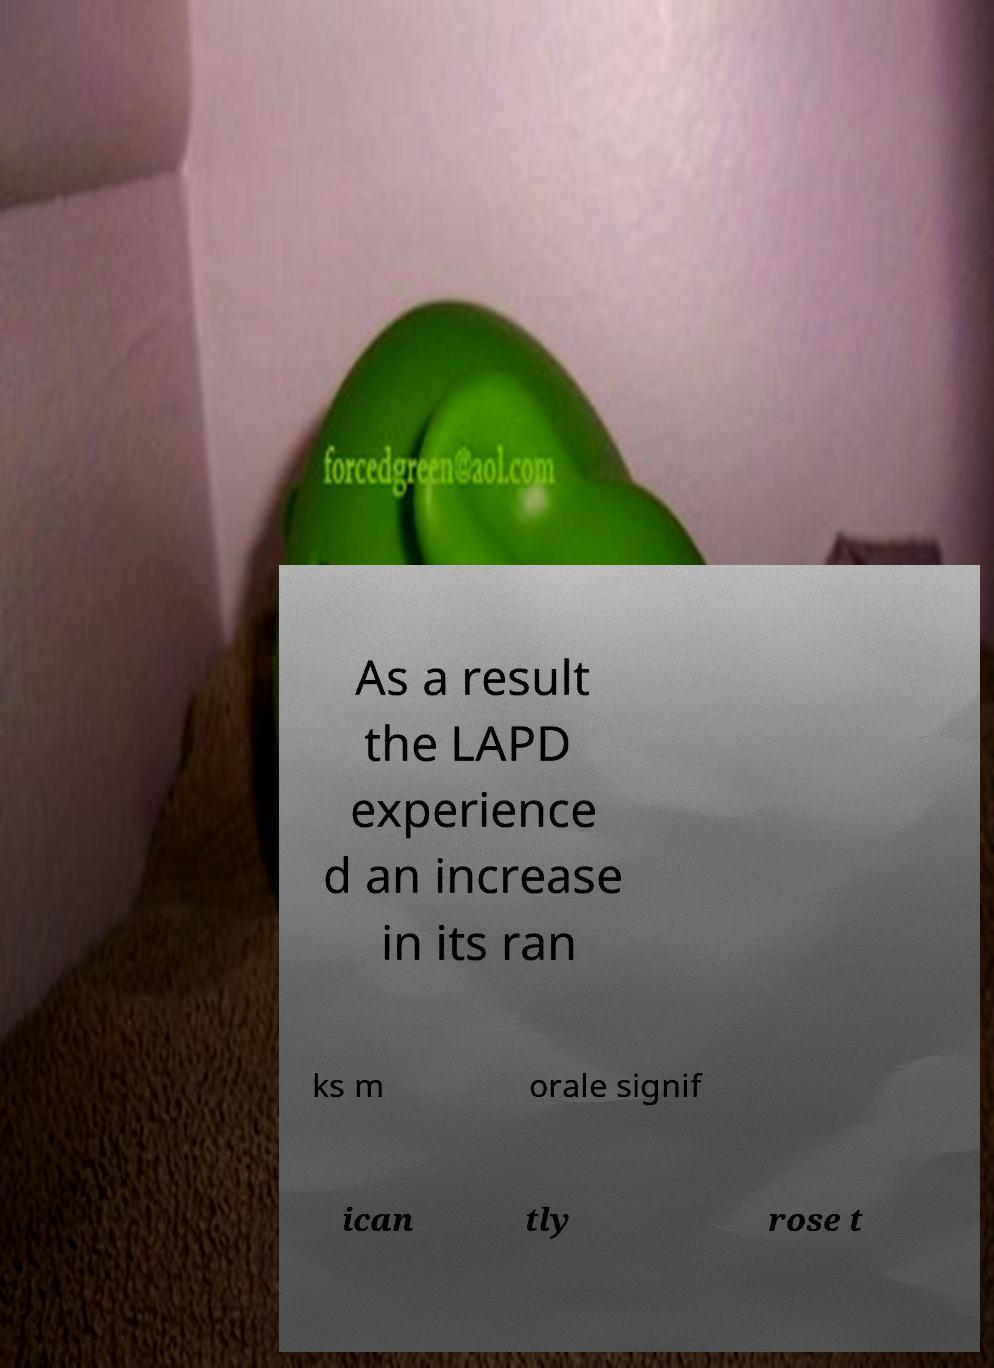Could you extract and type out the text from this image? As a result the LAPD experience d an increase in its ran ks m orale signif ican tly rose t 